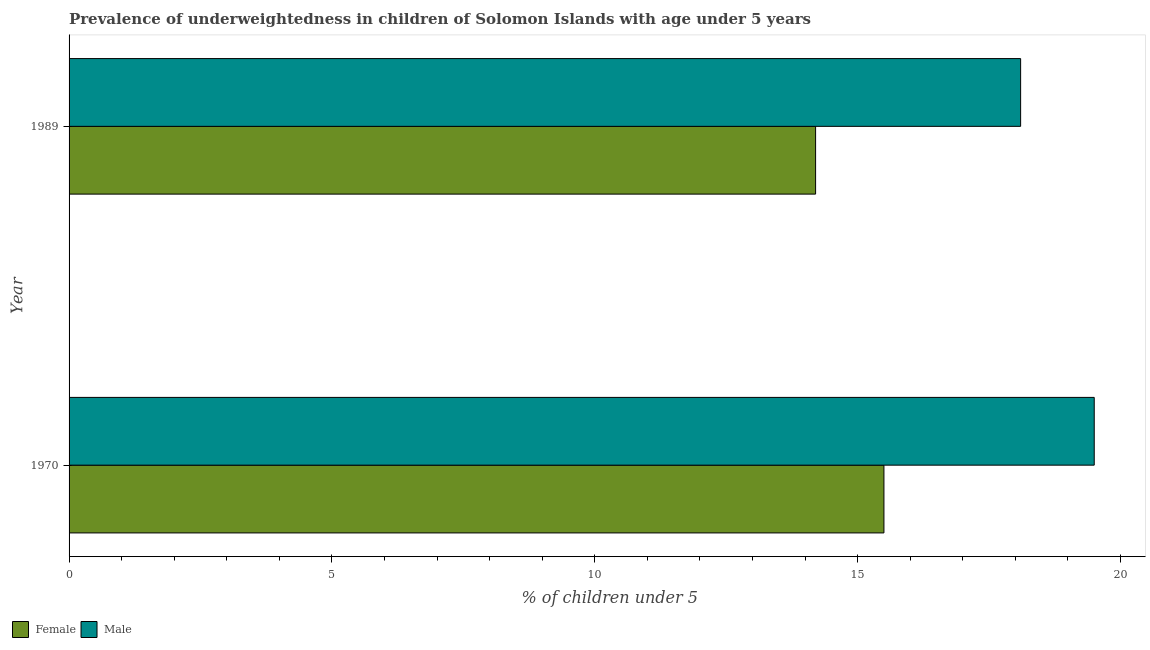How many bars are there on the 2nd tick from the bottom?
Your answer should be compact. 2. What is the label of the 1st group of bars from the top?
Your answer should be very brief. 1989. What is the percentage of underweighted male children in 1970?
Your response must be concise. 19.5. Across all years, what is the minimum percentage of underweighted male children?
Your response must be concise. 18.1. What is the total percentage of underweighted female children in the graph?
Offer a very short reply. 29.7. What is the difference between the percentage of underweighted female children in 1989 and the percentage of underweighted male children in 1970?
Give a very brief answer. -5.3. What is the average percentage of underweighted male children per year?
Offer a very short reply. 18.8. In the year 1989, what is the difference between the percentage of underweighted female children and percentage of underweighted male children?
Provide a short and direct response. -3.9. What is the ratio of the percentage of underweighted male children in 1970 to that in 1989?
Your answer should be compact. 1.08. What does the 2nd bar from the top in 1970 represents?
Offer a terse response. Female. Are all the bars in the graph horizontal?
Give a very brief answer. Yes. Are the values on the major ticks of X-axis written in scientific E-notation?
Keep it short and to the point. No. Does the graph contain any zero values?
Make the answer very short. No. Where does the legend appear in the graph?
Provide a succinct answer. Bottom left. How many legend labels are there?
Ensure brevity in your answer.  2. How are the legend labels stacked?
Provide a succinct answer. Horizontal. What is the title of the graph?
Ensure brevity in your answer.  Prevalence of underweightedness in children of Solomon Islands with age under 5 years. What is the label or title of the X-axis?
Your answer should be very brief.  % of children under 5. What is the label or title of the Y-axis?
Your answer should be very brief. Year. What is the  % of children under 5 in Female in 1970?
Your answer should be compact. 15.5. What is the  % of children under 5 in Female in 1989?
Your answer should be compact. 14.2. What is the  % of children under 5 in Male in 1989?
Ensure brevity in your answer.  18.1. Across all years, what is the maximum  % of children under 5 of Female?
Your answer should be compact. 15.5. Across all years, what is the maximum  % of children under 5 in Male?
Ensure brevity in your answer.  19.5. Across all years, what is the minimum  % of children under 5 of Female?
Your answer should be compact. 14.2. Across all years, what is the minimum  % of children under 5 in Male?
Offer a terse response. 18.1. What is the total  % of children under 5 of Female in the graph?
Keep it short and to the point. 29.7. What is the total  % of children under 5 of Male in the graph?
Make the answer very short. 37.6. What is the difference between the  % of children under 5 of Male in 1970 and that in 1989?
Offer a terse response. 1.4. What is the average  % of children under 5 in Female per year?
Offer a terse response. 14.85. What is the average  % of children under 5 in Male per year?
Provide a succinct answer. 18.8. In the year 1970, what is the difference between the  % of children under 5 in Female and  % of children under 5 in Male?
Offer a very short reply. -4. In the year 1989, what is the difference between the  % of children under 5 in Female and  % of children under 5 in Male?
Offer a very short reply. -3.9. What is the ratio of the  % of children under 5 in Female in 1970 to that in 1989?
Offer a very short reply. 1.09. What is the ratio of the  % of children under 5 of Male in 1970 to that in 1989?
Make the answer very short. 1.08. What is the difference between the highest and the second highest  % of children under 5 in Male?
Provide a short and direct response. 1.4. What is the difference between the highest and the lowest  % of children under 5 in Male?
Ensure brevity in your answer.  1.4. 